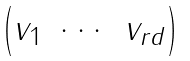Convert formula to latex. <formula><loc_0><loc_0><loc_500><loc_500>\begin{pmatrix} v _ { 1 } & \cdots & v _ { r d } \end{pmatrix}</formula> 